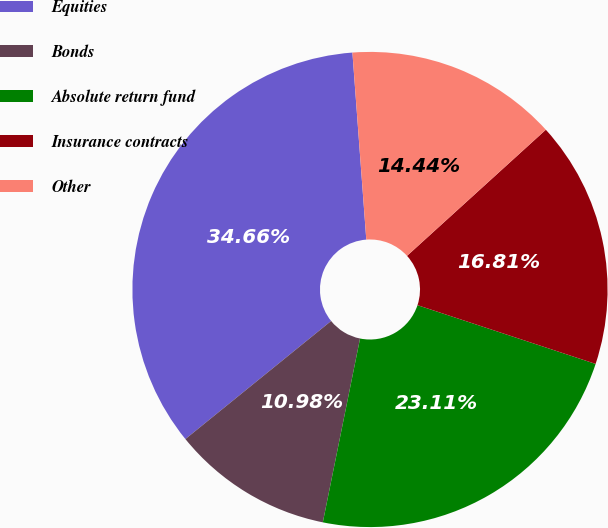Convert chart. <chart><loc_0><loc_0><loc_500><loc_500><pie_chart><fcel>Equities<fcel>Bonds<fcel>Absolute return fund<fcel>Insurance contracts<fcel>Other<nl><fcel>34.66%<fcel>10.98%<fcel>23.11%<fcel>16.81%<fcel>14.44%<nl></chart> 